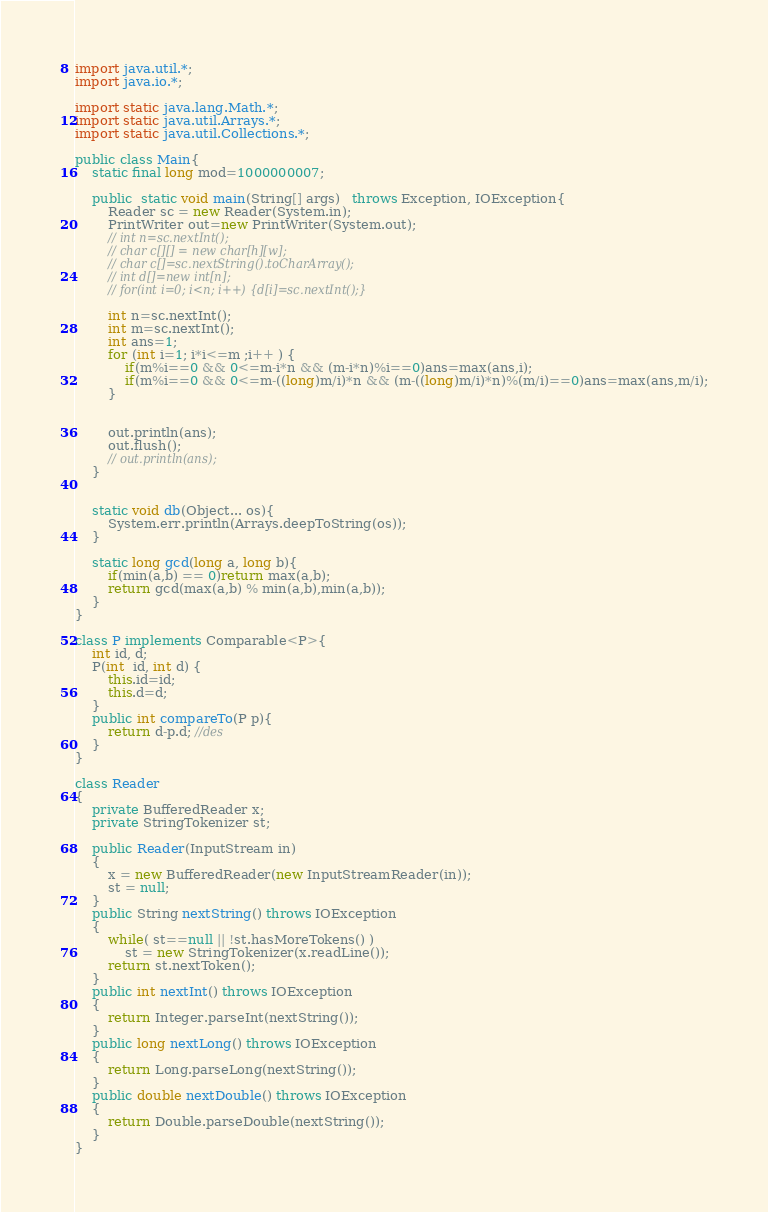<code> <loc_0><loc_0><loc_500><loc_500><_Java_>import java.util.*;
import java.io.*;
 
import static java.lang.Math.*;
import static java.util.Arrays.*;
import static java.util.Collections.*;
 
public class Main{
    static final long mod=1000000007;
    
    public  static void main(String[] args)   throws Exception, IOException{
        Reader sc = new Reader(System.in);
        PrintWriter out=new PrintWriter(System.out);
        // int n=sc.nextInt();
        // char c[][] = new char[h][w];
        // char c[]=sc.nextString().toCharArray();
        // int d[]=new int[n];
        // for(int i=0; i<n; i++) {d[i]=sc.nextInt();}

        int n=sc.nextInt();
        int m=sc.nextInt();
        int ans=1;
        for (int i=1; i*i<=m ;i++ ) {            
            if(m%i==0 && 0<=m-i*n && (m-i*n)%i==0)ans=max(ans,i);          
            if(m%i==0 && 0<=m-((long)m/i)*n && (m-((long)m/i)*n)%(m/i)==0)ans=max(ans,m/i);
        }


        out.println(ans);
        out.flush();
        // out.println(ans);
    }


    static void db(Object... os){
        System.err.println(Arrays.deepToString(os));
    }  

    static long gcd(long a, long b){
        if(min(a,b) == 0)return max(a,b);
        return gcd(max(a,b) % min(a,b),min(a,b));
    }
}

class P implements Comparable<P>{
    int id, d;
    P(int  id, int d) {
        this.id=id;
        this.d=d;
    }
    public int compareTo(P p){
        return d-p.d; //des
    }
}

class Reader
{ 
    private BufferedReader x;
    private StringTokenizer st;
    
    public Reader(InputStream in)
    {
        x = new BufferedReader(new InputStreamReader(in));
        st = null;
    }
    public String nextString() throws IOException
    {
        while( st==null || !st.hasMoreTokens() )
            st = new StringTokenizer(x.readLine());
        return st.nextToken();
    }
    public int nextInt() throws IOException
    {
        return Integer.parseInt(nextString());
    }
    public long nextLong() throws IOException
    {
        return Long.parseLong(nextString());
    }
    public double nextDouble() throws IOException
    {
        return Double.parseDouble(nextString());
    }
}
</code> 